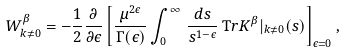<formula> <loc_0><loc_0><loc_500><loc_500>W ^ { \beta } _ { k \neq 0 } = - \frac { 1 } { 2 } \frac { \partial } { \partial \epsilon } \left [ \frac { \mu ^ { 2 \epsilon } } { \Gamma ( \epsilon ) } \int _ { 0 } ^ { \infty } \, \frac { { d } s } { s ^ { 1 - \epsilon } } \, { \mathrm T r } { K } ^ { \beta } | _ { k \neq 0 } ( s ) \right ] _ { \epsilon = 0 } ,</formula> 